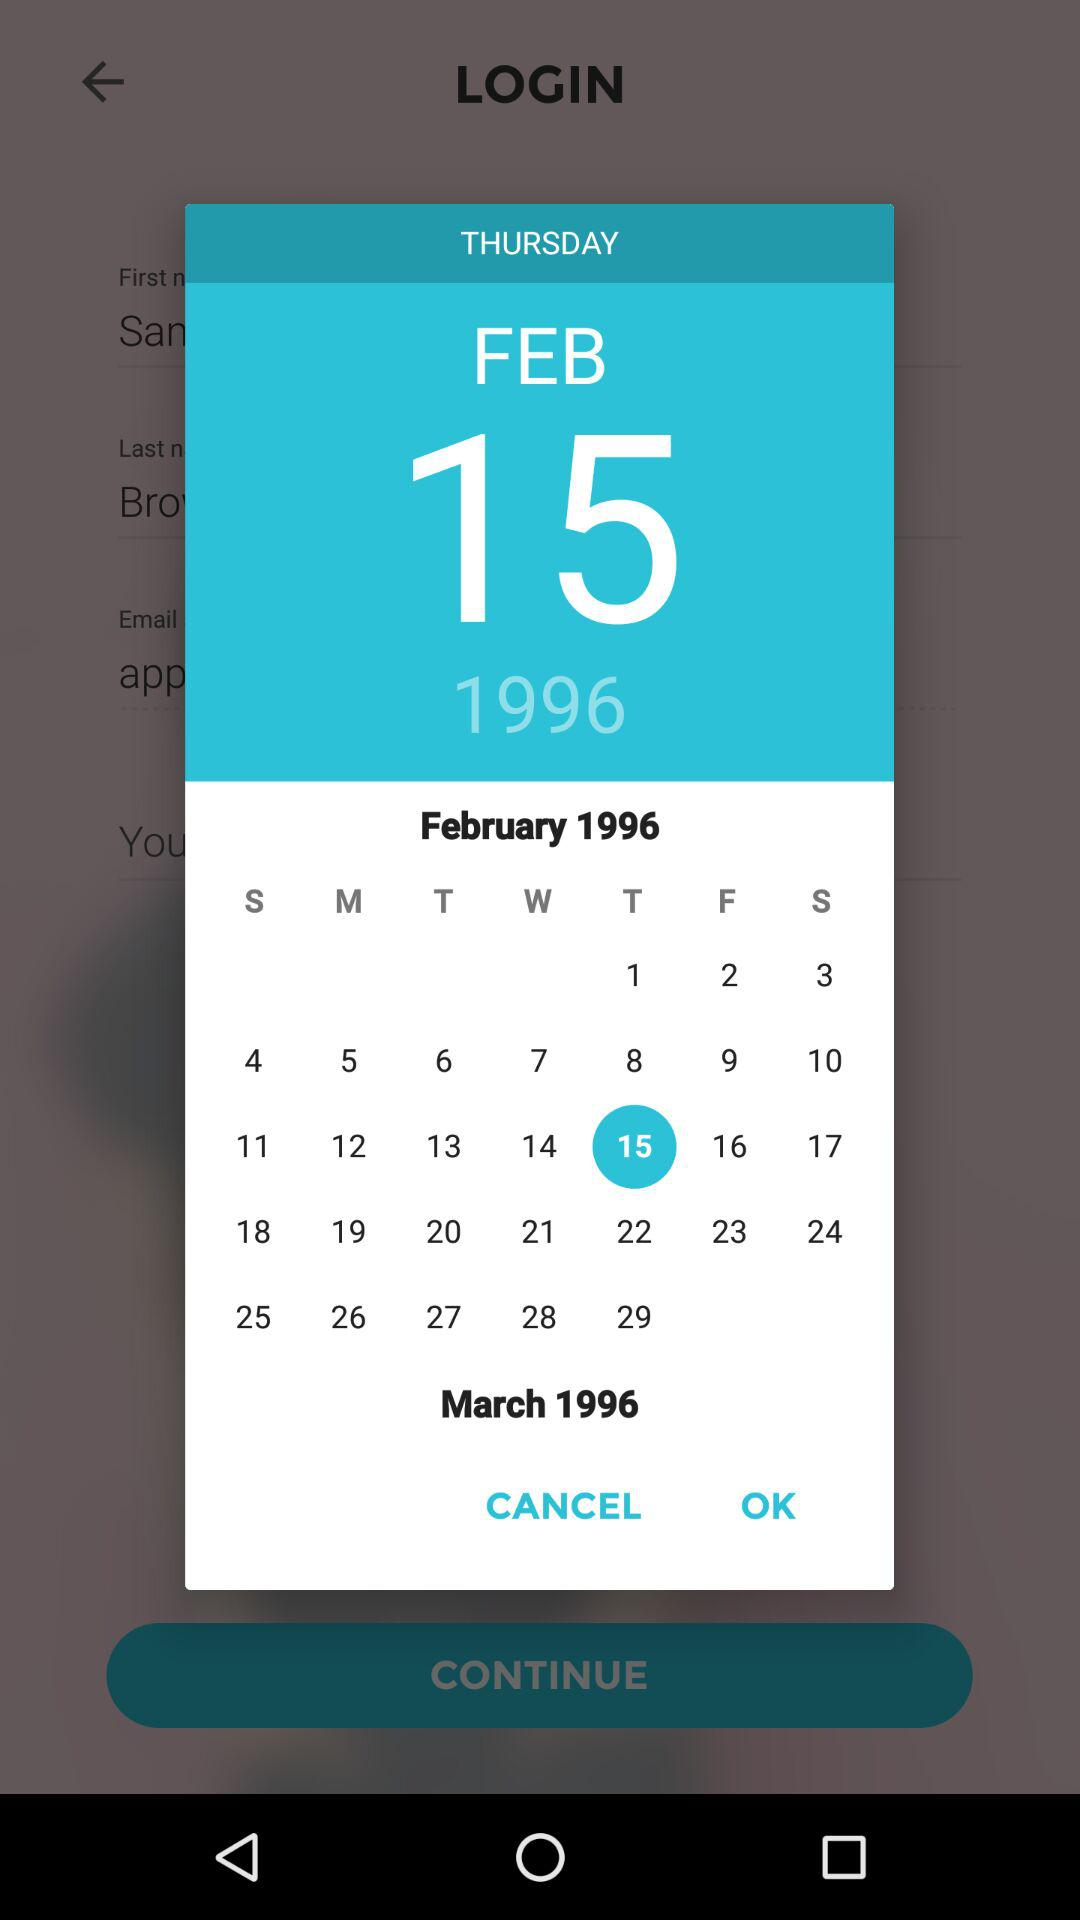What is the selected date? The selected date is Thursday, February 15, 1996. 